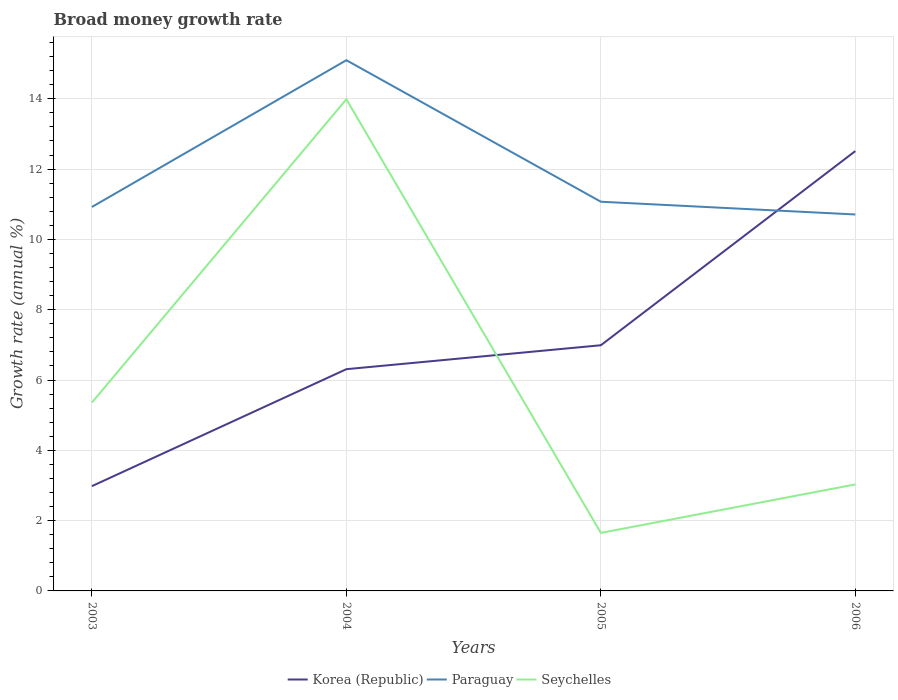Is the number of lines equal to the number of legend labels?
Give a very brief answer. Yes. Across all years, what is the maximum growth rate in Seychelles?
Give a very brief answer. 1.65. What is the total growth rate in Seychelles in the graph?
Ensure brevity in your answer.  10.96. What is the difference between the highest and the second highest growth rate in Korea (Republic)?
Keep it short and to the point. 9.53. What is the difference between the highest and the lowest growth rate in Korea (Republic)?
Your answer should be compact. 1. Is the growth rate in Korea (Republic) strictly greater than the growth rate in Seychelles over the years?
Ensure brevity in your answer.  No. How many lines are there?
Your answer should be very brief. 3. How many years are there in the graph?
Offer a terse response. 4. What is the difference between two consecutive major ticks on the Y-axis?
Provide a short and direct response. 2. Are the values on the major ticks of Y-axis written in scientific E-notation?
Provide a succinct answer. No. Does the graph contain grids?
Provide a short and direct response. Yes. Where does the legend appear in the graph?
Offer a very short reply. Bottom center. How are the legend labels stacked?
Give a very brief answer. Horizontal. What is the title of the graph?
Keep it short and to the point. Broad money growth rate. What is the label or title of the Y-axis?
Make the answer very short. Growth rate (annual %). What is the Growth rate (annual %) in Korea (Republic) in 2003?
Offer a very short reply. 2.98. What is the Growth rate (annual %) of Paraguay in 2003?
Make the answer very short. 10.92. What is the Growth rate (annual %) in Seychelles in 2003?
Keep it short and to the point. 5.36. What is the Growth rate (annual %) of Korea (Republic) in 2004?
Offer a terse response. 6.31. What is the Growth rate (annual %) of Paraguay in 2004?
Provide a succinct answer. 15.1. What is the Growth rate (annual %) of Seychelles in 2004?
Keep it short and to the point. 13.99. What is the Growth rate (annual %) in Korea (Republic) in 2005?
Provide a succinct answer. 6.99. What is the Growth rate (annual %) of Paraguay in 2005?
Provide a succinct answer. 11.07. What is the Growth rate (annual %) of Seychelles in 2005?
Your answer should be very brief. 1.65. What is the Growth rate (annual %) of Korea (Republic) in 2006?
Ensure brevity in your answer.  12.51. What is the Growth rate (annual %) of Paraguay in 2006?
Provide a short and direct response. 10.71. What is the Growth rate (annual %) of Seychelles in 2006?
Your response must be concise. 3.03. Across all years, what is the maximum Growth rate (annual %) of Korea (Republic)?
Your answer should be very brief. 12.51. Across all years, what is the maximum Growth rate (annual %) in Paraguay?
Provide a succinct answer. 15.1. Across all years, what is the maximum Growth rate (annual %) of Seychelles?
Your answer should be compact. 13.99. Across all years, what is the minimum Growth rate (annual %) in Korea (Republic)?
Give a very brief answer. 2.98. Across all years, what is the minimum Growth rate (annual %) in Paraguay?
Your response must be concise. 10.71. Across all years, what is the minimum Growth rate (annual %) of Seychelles?
Provide a short and direct response. 1.65. What is the total Growth rate (annual %) of Korea (Republic) in the graph?
Provide a succinct answer. 28.79. What is the total Growth rate (annual %) of Paraguay in the graph?
Offer a very short reply. 47.8. What is the total Growth rate (annual %) of Seychelles in the graph?
Offer a very short reply. 24.03. What is the difference between the Growth rate (annual %) of Korea (Republic) in 2003 and that in 2004?
Give a very brief answer. -3.33. What is the difference between the Growth rate (annual %) of Paraguay in 2003 and that in 2004?
Ensure brevity in your answer.  -4.18. What is the difference between the Growth rate (annual %) in Seychelles in 2003 and that in 2004?
Offer a terse response. -8.63. What is the difference between the Growth rate (annual %) of Korea (Republic) in 2003 and that in 2005?
Make the answer very short. -4.01. What is the difference between the Growth rate (annual %) of Paraguay in 2003 and that in 2005?
Your response must be concise. -0.15. What is the difference between the Growth rate (annual %) of Seychelles in 2003 and that in 2005?
Provide a short and direct response. 3.71. What is the difference between the Growth rate (annual %) in Korea (Republic) in 2003 and that in 2006?
Provide a short and direct response. -9.53. What is the difference between the Growth rate (annual %) of Paraguay in 2003 and that in 2006?
Offer a very short reply. 0.21. What is the difference between the Growth rate (annual %) in Seychelles in 2003 and that in 2006?
Make the answer very short. 2.33. What is the difference between the Growth rate (annual %) in Korea (Republic) in 2004 and that in 2005?
Provide a succinct answer. -0.68. What is the difference between the Growth rate (annual %) of Paraguay in 2004 and that in 2005?
Your answer should be compact. 4.03. What is the difference between the Growth rate (annual %) in Seychelles in 2004 and that in 2005?
Your answer should be compact. 12.34. What is the difference between the Growth rate (annual %) in Korea (Republic) in 2004 and that in 2006?
Provide a short and direct response. -6.2. What is the difference between the Growth rate (annual %) of Paraguay in 2004 and that in 2006?
Offer a very short reply. 4.39. What is the difference between the Growth rate (annual %) in Seychelles in 2004 and that in 2006?
Your answer should be compact. 10.96. What is the difference between the Growth rate (annual %) of Korea (Republic) in 2005 and that in 2006?
Make the answer very short. -5.52. What is the difference between the Growth rate (annual %) in Paraguay in 2005 and that in 2006?
Offer a very short reply. 0.36. What is the difference between the Growth rate (annual %) in Seychelles in 2005 and that in 2006?
Ensure brevity in your answer.  -1.38. What is the difference between the Growth rate (annual %) of Korea (Republic) in 2003 and the Growth rate (annual %) of Paraguay in 2004?
Give a very brief answer. -12.12. What is the difference between the Growth rate (annual %) of Korea (Republic) in 2003 and the Growth rate (annual %) of Seychelles in 2004?
Offer a terse response. -11.01. What is the difference between the Growth rate (annual %) of Paraguay in 2003 and the Growth rate (annual %) of Seychelles in 2004?
Your answer should be compact. -3.06. What is the difference between the Growth rate (annual %) of Korea (Republic) in 2003 and the Growth rate (annual %) of Paraguay in 2005?
Keep it short and to the point. -8.09. What is the difference between the Growth rate (annual %) of Korea (Republic) in 2003 and the Growth rate (annual %) of Seychelles in 2005?
Your answer should be very brief. 1.33. What is the difference between the Growth rate (annual %) in Paraguay in 2003 and the Growth rate (annual %) in Seychelles in 2005?
Ensure brevity in your answer.  9.27. What is the difference between the Growth rate (annual %) of Korea (Republic) in 2003 and the Growth rate (annual %) of Paraguay in 2006?
Your answer should be compact. -7.73. What is the difference between the Growth rate (annual %) of Korea (Republic) in 2003 and the Growth rate (annual %) of Seychelles in 2006?
Your answer should be compact. -0.05. What is the difference between the Growth rate (annual %) in Paraguay in 2003 and the Growth rate (annual %) in Seychelles in 2006?
Your response must be concise. 7.89. What is the difference between the Growth rate (annual %) in Korea (Republic) in 2004 and the Growth rate (annual %) in Paraguay in 2005?
Offer a very short reply. -4.76. What is the difference between the Growth rate (annual %) in Korea (Republic) in 2004 and the Growth rate (annual %) in Seychelles in 2005?
Provide a short and direct response. 4.66. What is the difference between the Growth rate (annual %) of Paraguay in 2004 and the Growth rate (annual %) of Seychelles in 2005?
Provide a succinct answer. 13.45. What is the difference between the Growth rate (annual %) in Korea (Republic) in 2004 and the Growth rate (annual %) in Paraguay in 2006?
Provide a succinct answer. -4.4. What is the difference between the Growth rate (annual %) in Korea (Republic) in 2004 and the Growth rate (annual %) in Seychelles in 2006?
Give a very brief answer. 3.28. What is the difference between the Growth rate (annual %) of Paraguay in 2004 and the Growth rate (annual %) of Seychelles in 2006?
Make the answer very short. 12.07. What is the difference between the Growth rate (annual %) in Korea (Republic) in 2005 and the Growth rate (annual %) in Paraguay in 2006?
Offer a terse response. -3.72. What is the difference between the Growth rate (annual %) of Korea (Republic) in 2005 and the Growth rate (annual %) of Seychelles in 2006?
Your answer should be compact. 3.96. What is the difference between the Growth rate (annual %) in Paraguay in 2005 and the Growth rate (annual %) in Seychelles in 2006?
Offer a terse response. 8.04. What is the average Growth rate (annual %) in Korea (Republic) per year?
Offer a terse response. 7.2. What is the average Growth rate (annual %) of Paraguay per year?
Provide a succinct answer. 11.95. What is the average Growth rate (annual %) in Seychelles per year?
Provide a succinct answer. 6.01. In the year 2003, what is the difference between the Growth rate (annual %) of Korea (Republic) and Growth rate (annual %) of Paraguay?
Your response must be concise. -7.94. In the year 2003, what is the difference between the Growth rate (annual %) of Korea (Republic) and Growth rate (annual %) of Seychelles?
Provide a short and direct response. -2.38. In the year 2003, what is the difference between the Growth rate (annual %) in Paraguay and Growth rate (annual %) in Seychelles?
Offer a very short reply. 5.56. In the year 2004, what is the difference between the Growth rate (annual %) of Korea (Republic) and Growth rate (annual %) of Paraguay?
Your answer should be very brief. -8.79. In the year 2004, what is the difference between the Growth rate (annual %) in Korea (Republic) and Growth rate (annual %) in Seychelles?
Make the answer very short. -7.68. In the year 2004, what is the difference between the Growth rate (annual %) of Paraguay and Growth rate (annual %) of Seychelles?
Ensure brevity in your answer.  1.11. In the year 2005, what is the difference between the Growth rate (annual %) of Korea (Republic) and Growth rate (annual %) of Paraguay?
Your answer should be compact. -4.08. In the year 2005, what is the difference between the Growth rate (annual %) in Korea (Republic) and Growth rate (annual %) in Seychelles?
Your response must be concise. 5.34. In the year 2005, what is the difference between the Growth rate (annual %) in Paraguay and Growth rate (annual %) in Seychelles?
Offer a very short reply. 9.42. In the year 2006, what is the difference between the Growth rate (annual %) in Korea (Republic) and Growth rate (annual %) in Paraguay?
Your answer should be compact. 1.8. In the year 2006, what is the difference between the Growth rate (annual %) in Korea (Republic) and Growth rate (annual %) in Seychelles?
Offer a terse response. 9.48. In the year 2006, what is the difference between the Growth rate (annual %) of Paraguay and Growth rate (annual %) of Seychelles?
Ensure brevity in your answer.  7.68. What is the ratio of the Growth rate (annual %) of Korea (Republic) in 2003 to that in 2004?
Offer a terse response. 0.47. What is the ratio of the Growth rate (annual %) of Paraguay in 2003 to that in 2004?
Your response must be concise. 0.72. What is the ratio of the Growth rate (annual %) of Seychelles in 2003 to that in 2004?
Make the answer very short. 0.38. What is the ratio of the Growth rate (annual %) of Korea (Republic) in 2003 to that in 2005?
Make the answer very short. 0.43. What is the ratio of the Growth rate (annual %) of Paraguay in 2003 to that in 2005?
Keep it short and to the point. 0.99. What is the ratio of the Growth rate (annual %) of Seychelles in 2003 to that in 2005?
Provide a short and direct response. 3.24. What is the ratio of the Growth rate (annual %) in Korea (Republic) in 2003 to that in 2006?
Provide a short and direct response. 0.24. What is the ratio of the Growth rate (annual %) of Paraguay in 2003 to that in 2006?
Offer a very short reply. 1.02. What is the ratio of the Growth rate (annual %) in Seychelles in 2003 to that in 2006?
Your answer should be very brief. 1.77. What is the ratio of the Growth rate (annual %) in Korea (Republic) in 2004 to that in 2005?
Provide a succinct answer. 0.9. What is the ratio of the Growth rate (annual %) of Paraguay in 2004 to that in 2005?
Ensure brevity in your answer.  1.36. What is the ratio of the Growth rate (annual %) in Seychelles in 2004 to that in 2005?
Give a very brief answer. 8.47. What is the ratio of the Growth rate (annual %) in Korea (Republic) in 2004 to that in 2006?
Provide a succinct answer. 0.5. What is the ratio of the Growth rate (annual %) of Paraguay in 2004 to that in 2006?
Offer a terse response. 1.41. What is the ratio of the Growth rate (annual %) in Seychelles in 2004 to that in 2006?
Keep it short and to the point. 4.62. What is the ratio of the Growth rate (annual %) of Korea (Republic) in 2005 to that in 2006?
Provide a short and direct response. 0.56. What is the ratio of the Growth rate (annual %) of Paraguay in 2005 to that in 2006?
Your answer should be compact. 1.03. What is the ratio of the Growth rate (annual %) of Seychelles in 2005 to that in 2006?
Your response must be concise. 0.54. What is the difference between the highest and the second highest Growth rate (annual %) in Korea (Republic)?
Ensure brevity in your answer.  5.52. What is the difference between the highest and the second highest Growth rate (annual %) in Paraguay?
Give a very brief answer. 4.03. What is the difference between the highest and the second highest Growth rate (annual %) of Seychelles?
Your response must be concise. 8.63. What is the difference between the highest and the lowest Growth rate (annual %) of Korea (Republic)?
Make the answer very short. 9.53. What is the difference between the highest and the lowest Growth rate (annual %) of Paraguay?
Your answer should be compact. 4.39. What is the difference between the highest and the lowest Growth rate (annual %) in Seychelles?
Your response must be concise. 12.34. 